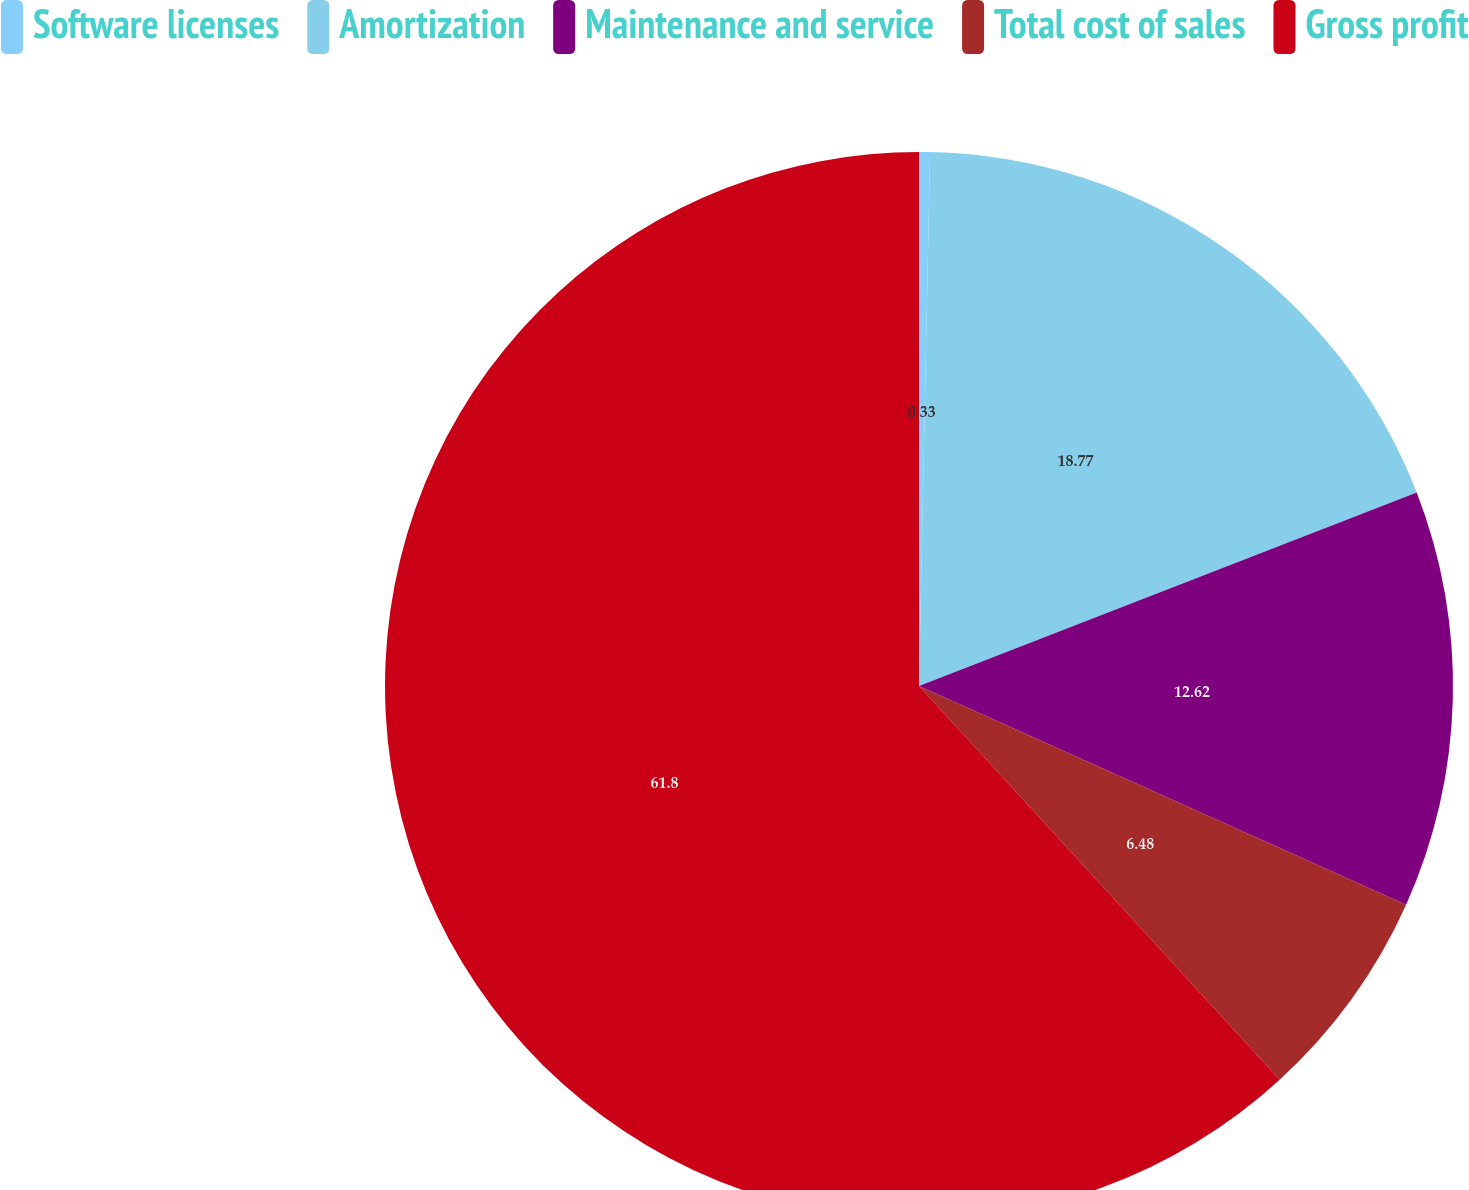Convert chart. <chart><loc_0><loc_0><loc_500><loc_500><pie_chart><fcel>Software licenses<fcel>Amortization<fcel>Maintenance and service<fcel>Total cost of sales<fcel>Gross profit<nl><fcel>0.33%<fcel>18.77%<fcel>12.62%<fcel>6.48%<fcel>61.8%<nl></chart> 